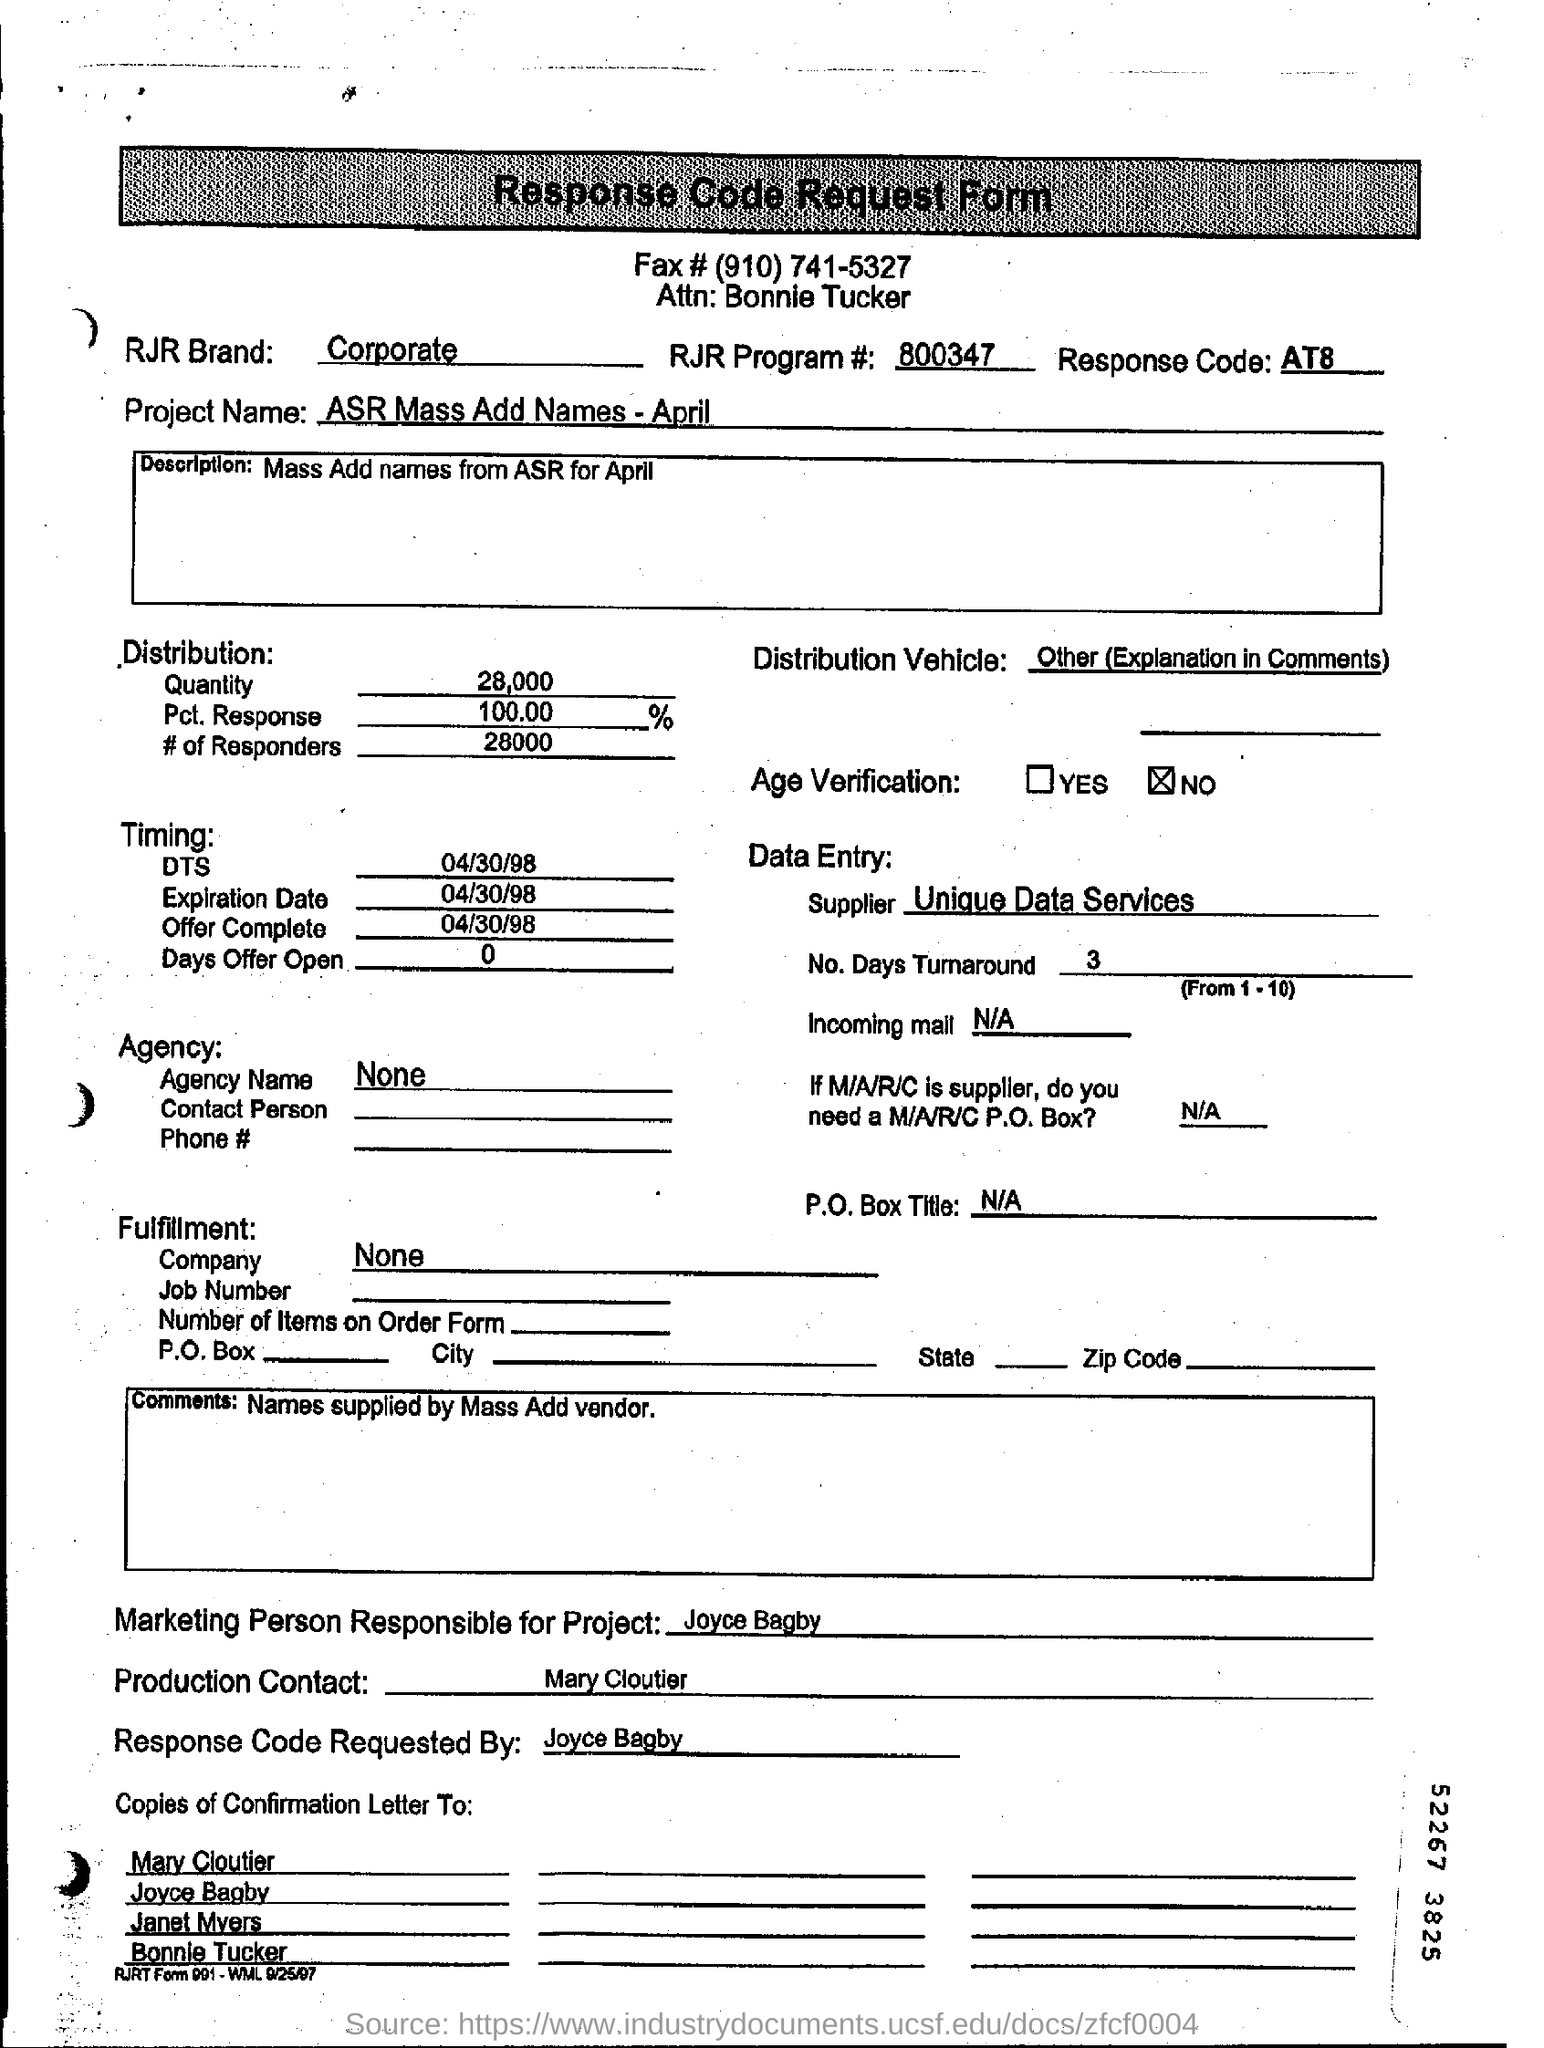Who is the marketing person responsible for Project?
Give a very brief answer. Joyce Bagby. What is the Response Code mentioned?
Offer a very short reply. AT8. Who is the Production contact ?
Keep it short and to the point. Mary Cloutier. What is the quantity of distribution ?
Keep it short and to the point. 28,000. What is the RJR Program # ?
Ensure brevity in your answer.  800347. 